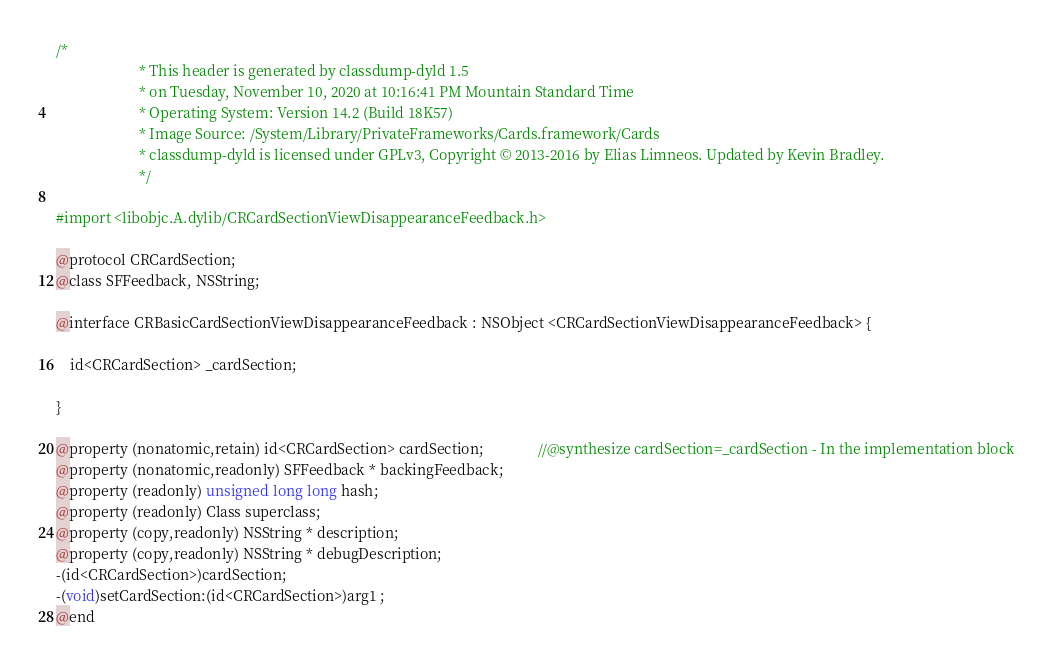Convert code to text. <code><loc_0><loc_0><loc_500><loc_500><_C_>/*
                       * This header is generated by classdump-dyld 1.5
                       * on Tuesday, November 10, 2020 at 10:16:41 PM Mountain Standard Time
                       * Operating System: Version 14.2 (Build 18K57)
                       * Image Source: /System/Library/PrivateFrameworks/Cards.framework/Cards
                       * classdump-dyld is licensed under GPLv3, Copyright © 2013-2016 by Elias Limneos. Updated by Kevin Bradley.
                       */

#import <libobjc.A.dylib/CRCardSectionViewDisappearanceFeedback.h>

@protocol CRCardSection;
@class SFFeedback, NSString;

@interface CRBasicCardSectionViewDisappearanceFeedback : NSObject <CRCardSectionViewDisappearanceFeedback> {

	id<CRCardSection> _cardSection;

}

@property (nonatomic,retain) id<CRCardSection> cardSection;               //@synthesize cardSection=_cardSection - In the implementation block
@property (nonatomic,readonly) SFFeedback * backingFeedback; 
@property (readonly) unsigned long long hash; 
@property (readonly) Class superclass; 
@property (copy,readonly) NSString * description; 
@property (copy,readonly) NSString * debugDescription; 
-(id<CRCardSection>)cardSection;
-(void)setCardSection:(id<CRCardSection>)arg1 ;
@end

</code> 